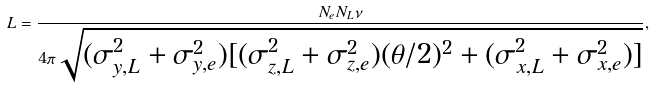<formula> <loc_0><loc_0><loc_500><loc_500>L = \frac { N _ { e } N _ { L } \nu } { 4 \pi \sqrt { ( \sigma _ { y , L } ^ { 2 } + \sigma _ { y , e } ^ { 2 } ) [ ( \sigma _ { z , L } ^ { 2 } + \sigma _ { z , e } ^ { 2 } ) ( \theta / 2 ) ^ { 2 } + ( \sigma _ { x , L } ^ { 2 } + \sigma _ { x , e } ^ { 2 } ) ] } } ,</formula> 